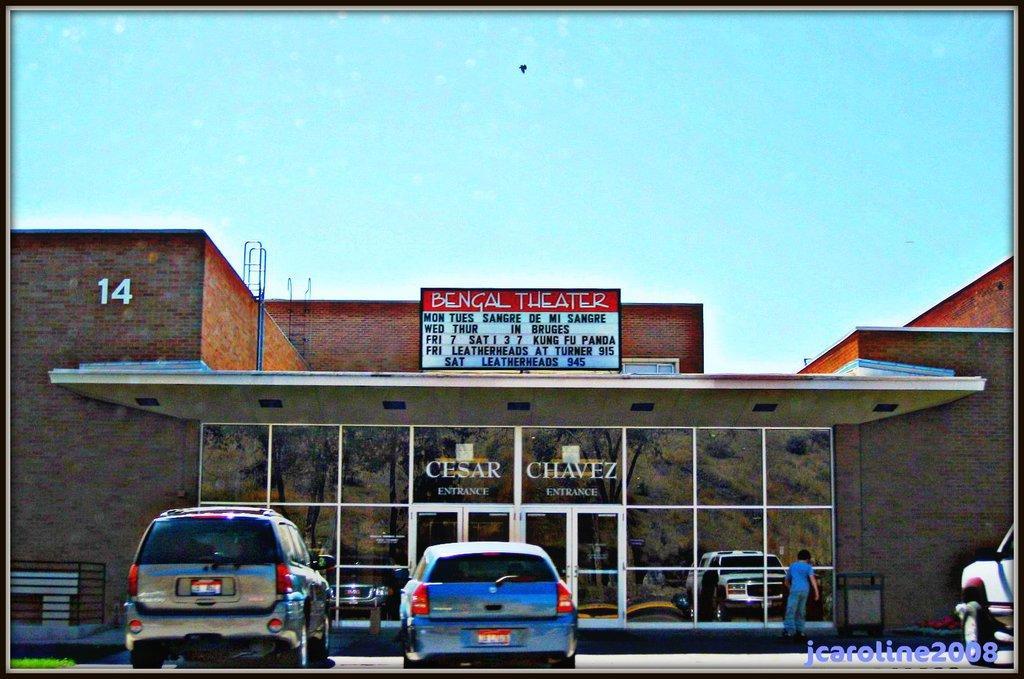Please provide a concise description of this image. In the picture it looks like a movie theater, there are few vehicles parked in front of the theater and on the right side there is a person. 